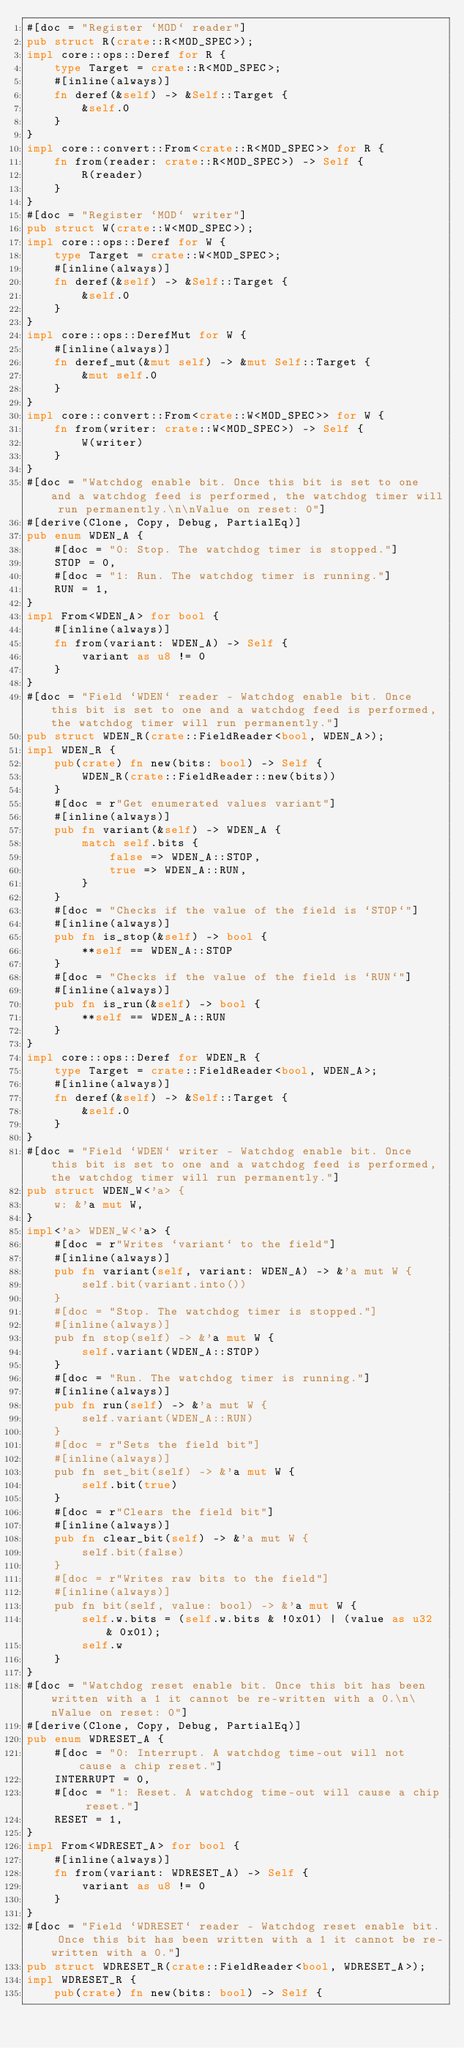<code> <loc_0><loc_0><loc_500><loc_500><_Rust_>#[doc = "Register `MOD` reader"]
pub struct R(crate::R<MOD_SPEC>);
impl core::ops::Deref for R {
    type Target = crate::R<MOD_SPEC>;
    #[inline(always)]
    fn deref(&self) -> &Self::Target {
        &self.0
    }
}
impl core::convert::From<crate::R<MOD_SPEC>> for R {
    fn from(reader: crate::R<MOD_SPEC>) -> Self {
        R(reader)
    }
}
#[doc = "Register `MOD` writer"]
pub struct W(crate::W<MOD_SPEC>);
impl core::ops::Deref for W {
    type Target = crate::W<MOD_SPEC>;
    #[inline(always)]
    fn deref(&self) -> &Self::Target {
        &self.0
    }
}
impl core::ops::DerefMut for W {
    #[inline(always)]
    fn deref_mut(&mut self) -> &mut Self::Target {
        &mut self.0
    }
}
impl core::convert::From<crate::W<MOD_SPEC>> for W {
    fn from(writer: crate::W<MOD_SPEC>) -> Self {
        W(writer)
    }
}
#[doc = "Watchdog enable bit. Once this bit is set to one and a watchdog feed is performed, the watchdog timer will run permanently.\n\nValue on reset: 0"]
#[derive(Clone, Copy, Debug, PartialEq)]
pub enum WDEN_A {
    #[doc = "0: Stop. The watchdog timer is stopped."]
    STOP = 0,
    #[doc = "1: Run. The watchdog timer is running."]
    RUN = 1,
}
impl From<WDEN_A> for bool {
    #[inline(always)]
    fn from(variant: WDEN_A) -> Self {
        variant as u8 != 0
    }
}
#[doc = "Field `WDEN` reader - Watchdog enable bit. Once this bit is set to one and a watchdog feed is performed, the watchdog timer will run permanently."]
pub struct WDEN_R(crate::FieldReader<bool, WDEN_A>);
impl WDEN_R {
    pub(crate) fn new(bits: bool) -> Self {
        WDEN_R(crate::FieldReader::new(bits))
    }
    #[doc = r"Get enumerated values variant"]
    #[inline(always)]
    pub fn variant(&self) -> WDEN_A {
        match self.bits {
            false => WDEN_A::STOP,
            true => WDEN_A::RUN,
        }
    }
    #[doc = "Checks if the value of the field is `STOP`"]
    #[inline(always)]
    pub fn is_stop(&self) -> bool {
        **self == WDEN_A::STOP
    }
    #[doc = "Checks if the value of the field is `RUN`"]
    #[inline(always)]
    pub fn is_run(&self) -> bool {
        **self == WDEN_A::RUN
    }
}
impl core::ops::Deref for WDEN_R {
    type Target = crate::FieldReader<bool, WDEN_A>;
    #[inline(always)]
    fn deref(&self) -> &Self::Target {
        &self.0
    }
}
#[doc = "Field `WDEN` writer - Watchdog enable bit. Once this bit is set to one and a watchdog feed is performed, the watchdog timer will run permanently."]
pub struct WDEN_W<'a> {
    w: &'a mut W,
}
impl<'a> WDEN_W<'a> {
    #[doc = r"Writes `variant` to the field"]
    #[inline(always)]
    pub fn variant(self, variant: WDEN_A) -> &'a mut W {
        self.bit(variant.into())
    }
    #[doc = "Stop. The watchdog timer is stopped."]
    #[inline(always)]
    pub fn stop(self) -> &'a mut W {
        self.variant(WDEN_A::STOP)
    }
    #[doc = "Run. The watchdog timer is running."]
    #[inline(always)]
    pub fn run(self) -> &'a mut W {
        self.variant(WDEN_A::RUN)
    }
    #[doc = r"Sets the field bit"]
    #[inline(always)]
    pub fn set_bit(self) -> &'a mut W {
        self.bit(true)
    }
    #[doc = r"Clears the field bit"]
    #[inline(always)]
    pub fn clear_bit(self) -> &'a mut W {
        self.bit(false)
    }
    #[doc = r"Writes raw bits to the field"]
    #[inline(always)]
    pub fn bit(self, value: bool) -> &'a mut W {
        self.w.bits = (self.w.bits & !0x01) | (value as u32 & 0x01);
        self.w
    }
}
#[doc = "Watchdog reset enable bit. Once this bit has been written with a 1 it cannot be re-written with a 0.\n\nValue on reset: 0"]
#[derive(Clone, Copy, Debug, PartialEq)]
pub enum WDRESET_A {
    #[doc = "0: Interrupt. A watchdog time-out will not cause a chip reset."]
    INTERRUPT = 0,
    #[doc = "1: Reset. A watchdog time-out will cause a chip reset."]
    RESET = 1,
}
impl From<WDRESET_A> for bool {
    #[inline(always)]
    fn from(variant: WDRESET_A) -> Self {
        variant as u8 != 0
    }
}
#[doc = "Field `WDRESET` reader - Watchdog reset enable bit. Once this bit has been written with a 1 it cannot be re-written with a 0."]
pub struct WDRESET_R(crate::FieldReader<bool, WDRESET_A>);
impl WDRESET_R {
    pub(crate) fn new(bits: bool) -> Self {</code> 